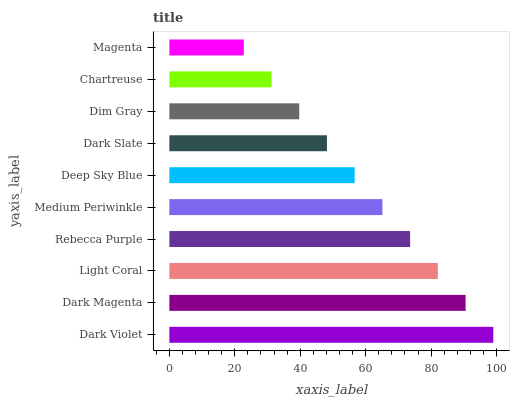Is Magenta the minimum?
Answer yes or no. Yes. Is Dark Violet the maximum?
Answer yes or no. Yes. Is Dark Magenta the minimum?
Answer yes or no. No. Is Dark Magenta the maximum?
Answer yes or no. No. Is Dark Violet greater than Dark Magenta?
Answer yes or no. Yes. Is Dark Magenta less than Dark Violet?
Answer yes or no. Yes. Is Dark Magenta greater than Dark Violet?
Answer yes or no. No. Is Dark Violet less than Dark Magenta?
Answer yes or no. No. Is Medium Periwinkle the high median?
Answer yes or no. Yes. Is Deep Sky Blue the low median?
Answer yes or no. Yes. Is Rebecca Purple the high median?
Answer yes or no. No. Is Dark Magenta the low median?
Answer yes or no. No. 